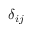Convert formula to latex. <formula><loc_0><loc_0><loc_500><loc_500>\delta _ { i j }</formula> 